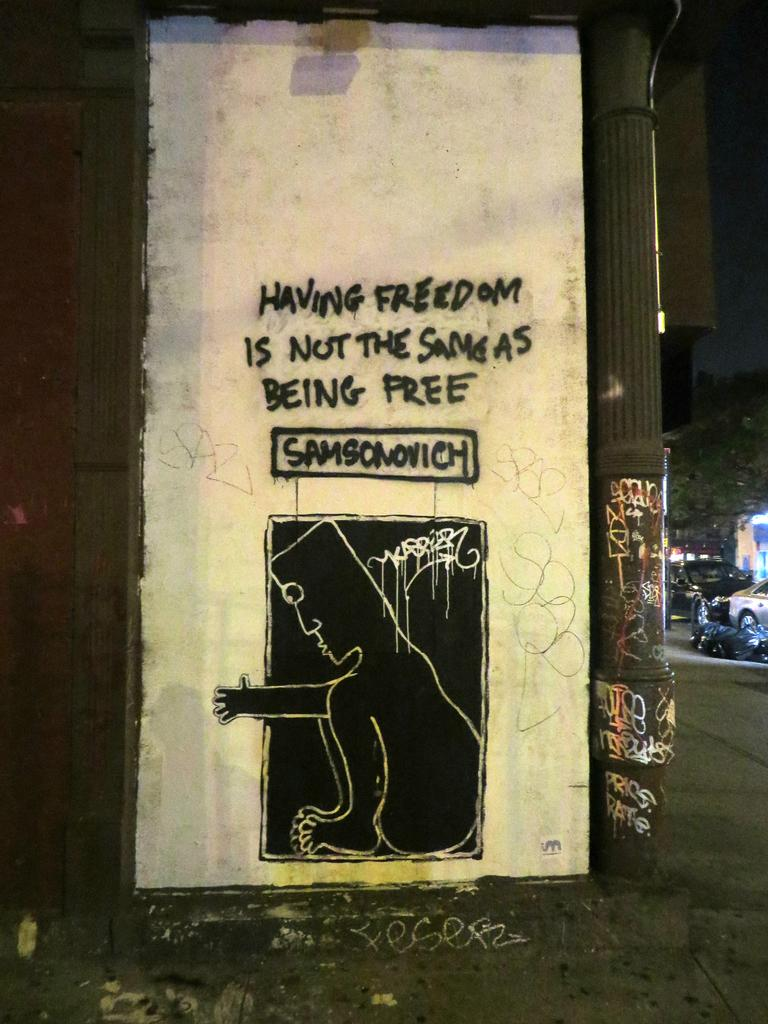Provide a one-sentence caption for the provided image. Street art that says Having Freedom is Not the Same As Being Free. 